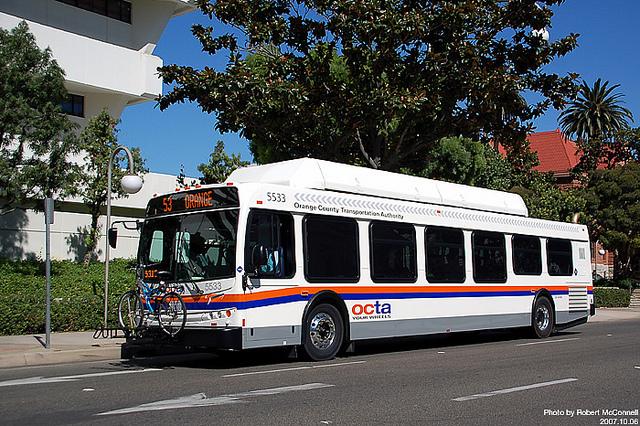Which county does this transportation vehicle belong to?
Give a very brief answer. Orange county. What four letter word is on the side of the bus?
Keep it brief. Octa. What color are the stripes?
Be succinct. Red and blue. 